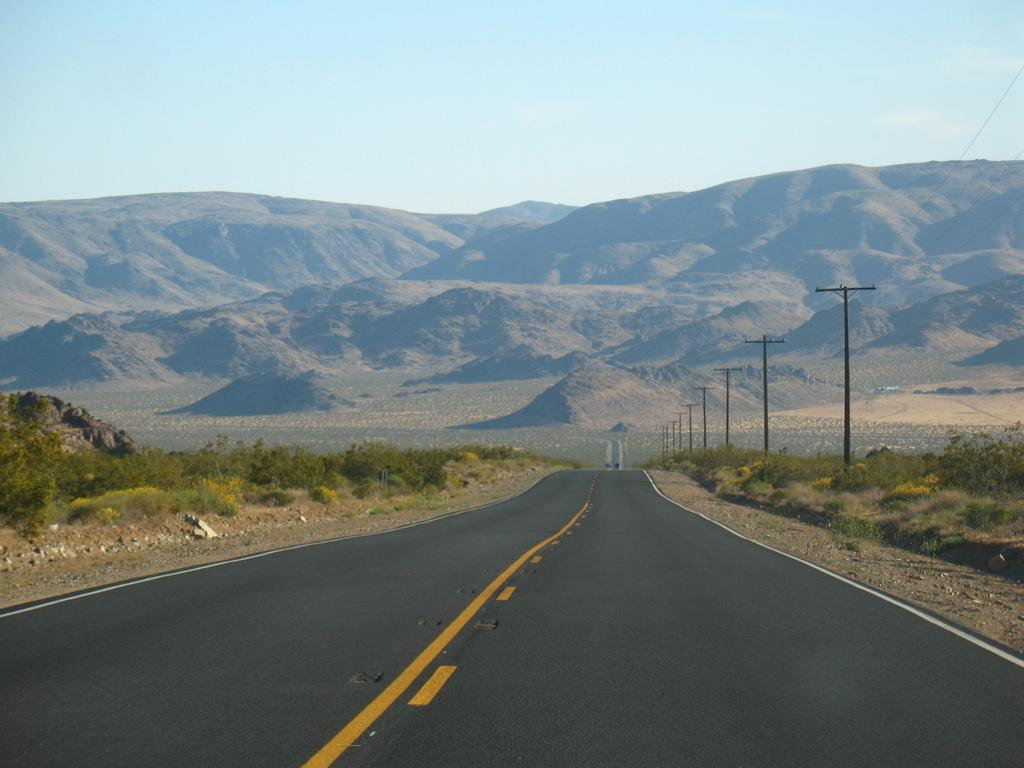What is located in the front of the image? There is a road, plants, and poles in the front of the image. What can be seen in the background of the image? There is a hill and the sky visible in the background of the image. What type of vegetation is present in the front of the image? The plants in the front of the image are the vegetation present. What is the condition of the sky in the image? The sky is visible in the background of the image. What type of lace can be seen on the hill in the image? There is no lace present on the hill in the image; it is a natural landscape. What appliance is causing trouble in the image? There is no appliance or indication of trouble in the image; it features a road, plants, poles, a hill, and the sky. 